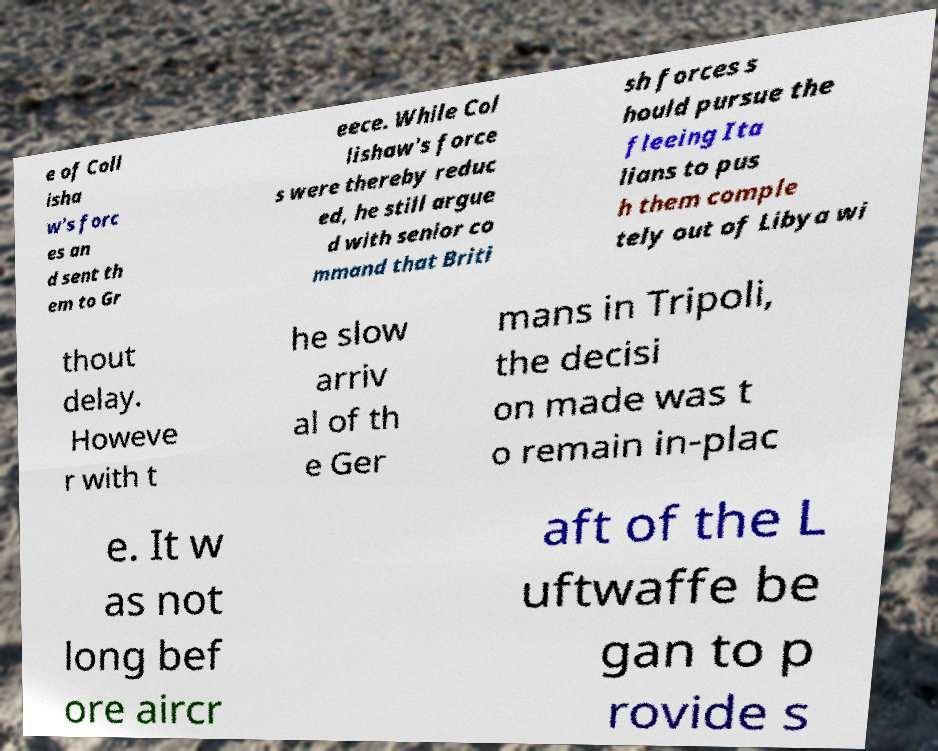Could you extract and type out the text from this image? e of Coll isha w's forc es an d sent th em to Gr eece. While Col lishaw's force s were thereby reduc ed, he still argue d with senior co mmand that Briti sh forces s hould pursue the fleeing Ita lians to pus h them comple tely out of Libya wi thout delay. Howeve r with t he slow arriv al of th e Ger mans in Tripoli, the decisi on made was t o remain in-plac e. It w as not long bef ore aircr aft of the L uftwaffe be gan to p rovide s 